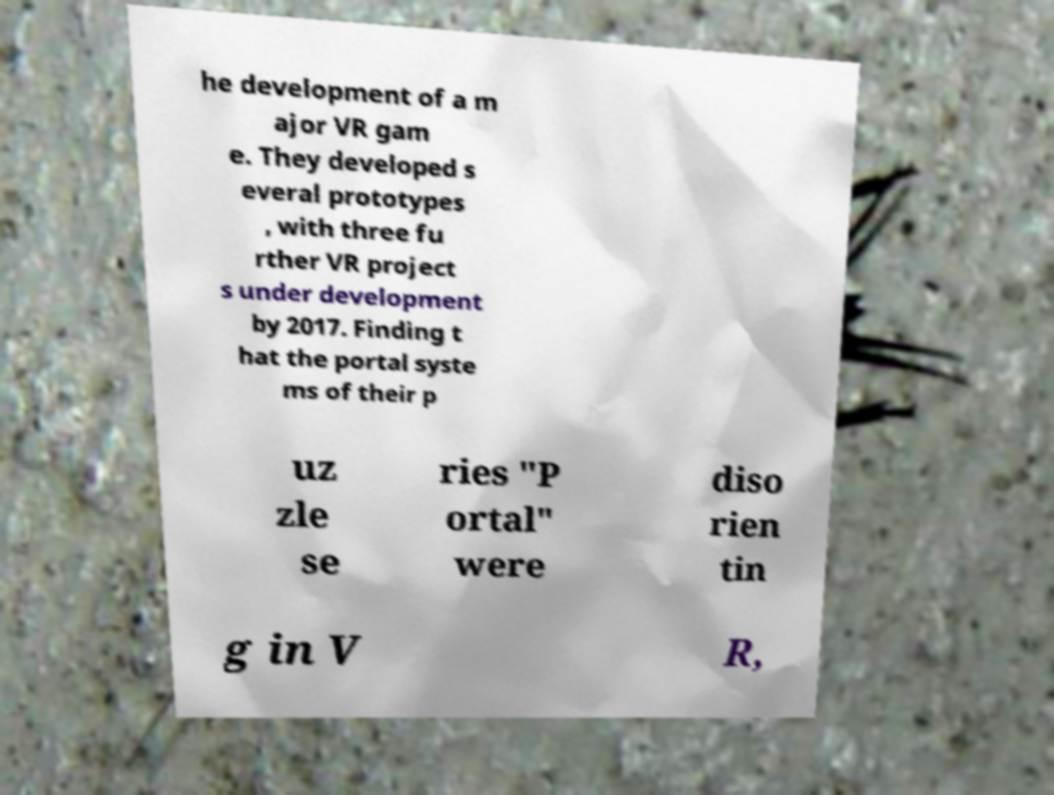There's text embedded in this image that I need extracted. Can you transcribe it verbatim? he development of a m ajor VR gam e. They developed s everal prototypes , with three fu rther VR project s under development by 2017. Finding t hat the portal syste ms of their p uz zle se ries "P ortal" were diso rien tin g in V R, 